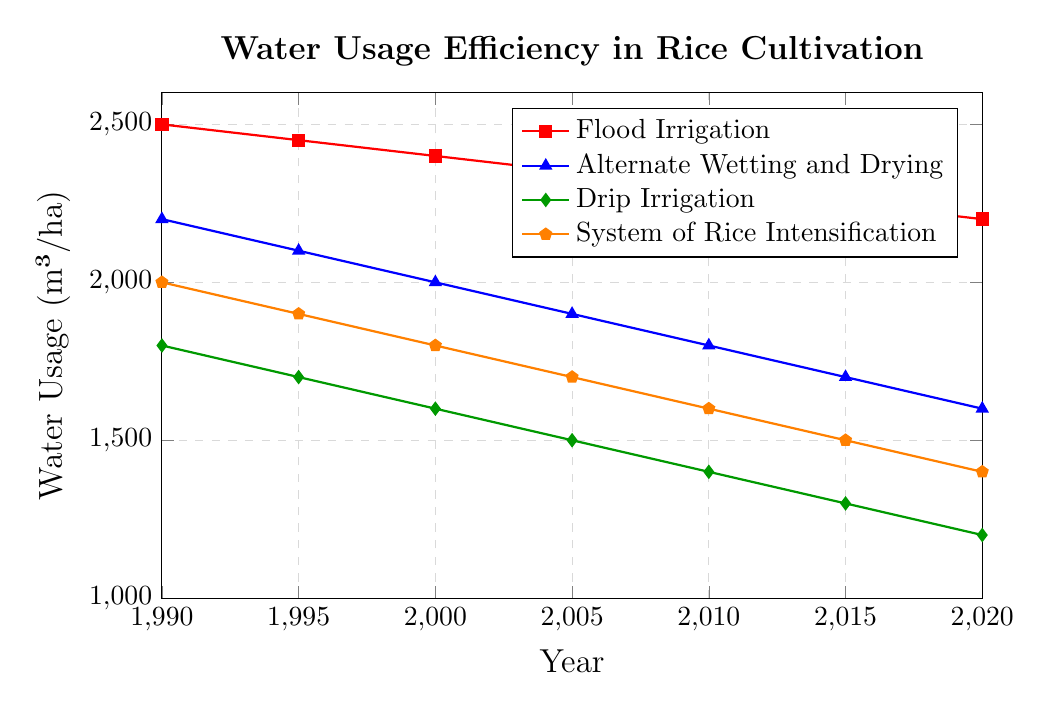What's the difference in water usage between Flood Irrigation and Drip Irrigation in 1990? To find the difference in water usage between Flood Irrigation and Drip Irrigation in 1990, subtract the water usage of Drip Irrigation (1800 m³/ha) from Flood Irrigation (2500 m³/ha): 2500 - 1800 = 700
Answer: 700 m³/ha Which irrigation method showed the greatest reduction in water usage from 1990 to 2020? Calculate the reduction in water usage for each irrigation method from 1990 to 2020:
Flood Irrigation: 2500 - 2200 = 300, Alternate Wetting and Drying: 2200 - 1600 = 600, Drip Irrigation: 1800 - 1200 = 600, System of Rice Intensification: 2000 - 1400 = 600. Since Alternate Wetting and Drying, Drip Irrigation, and System of Rice Intensification all reduced by the same amount, they showed the greatest reduction.
Answer: Alternate Wetting and Drying, Drip Irrigation, System of Rice Intensification Which irrigation method had the lowest water usage efficiency in 2010? Identify the water usage for each method in 2010: Flood Irrigation (2300 m³/ha), Alternate Wetting and Drying (1800 m³/ha), Drip Irrigation (1400 m³/ha), System of Rice Intensification (1600 m³/ha). The highest value indicates the lowest efficiency. Flood Irrigation has the highest value (2300 m³/ha).
Answer: Flood Irrigation For System of Rice Intensification, what was the average water usage from 1990 to 2020? Sum the water usage values for System of Rice Intensification from 1990 to 2020: (2000 + 1900 + 1800 + 1700 + 1600 + 1500 + 1400) = 11900. Since there are 7 data points, divide the sum by 7: 11900 / 7 ≈ 1700
Answer: 1700 m³/ha In what year did Alternate Wetting and Drying and Drip Irrigation have the same water usage efficiency? Compare the water usage values for both methods across each year. In each year, the values do not match. Therefore, there is no year when both methods have the same water usage efficiency.
Answer: None What is the trend of water usage efficiency over time for all methods? Observe the plot lines for each method. All show a decreasing trend in water usage over time, indicating improving efficiency.
Answer: Decreasing By how much did the water usage in System of Rice Intensification decrease from 2000 to 2010? Subtract the water usage of System of Rice Intensification in 2010 (1600 m³/ha) from its value in 2000 (1800 m³/ha): 1800 - 1600 = 200
Answer: 200 m³/ha Which irrigation method was the most consistent in terms of water usage reduction per 5-year period? Calculate the reduction per period for each method, comparing the consistency:
Flood Irrigation: 50, 50, 50, 50, 50, 50 (consistent)
Alternate Wetting and Drying: 100, 100, 100, 100, 100, 100 (consistent)
Drip Irrigation: 100, 100, 100, 100, 100, 100 (consistent)
System of Rice Intensification: 100, 100, 100, 100, 100, 100 (consistent)
Thus, all methods appear consistent in water usage reduction.
Answer: All methods Among all methods, which one had the smallest value in the year 2020? Identify the water usage values in 2020 for each method: Flood Irrigation (2200 m³/ha), Alternate Wetting and Drying (1600 m³/ha), Drip Irrigation (1200 m³/ha), System of Rice Intensification (1400 m³/ha). Drip Irrigation shows the smallest value.
Answer: Drip Irrigation 